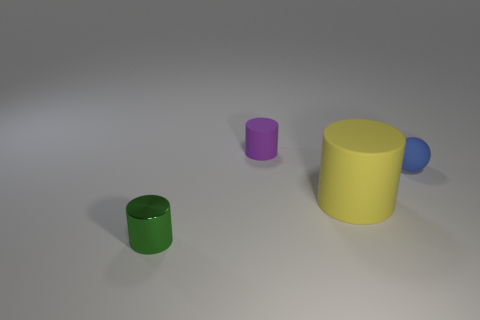How many objects are to the right of the tiny cylinder on the right side of the small cylinder to the left of the purple cylinder?
Provide a short and direct response. 2. Are there fewer large objects that are right of the blue thing than cylinders that are behind the shiny cylinder?
Your answer should be very brief. Yes. What color is the large object that is the same shape as the tiny green thing?
Ensure brevity in your answer.  Yellow. What size is the blue rubber thing?
Make the answer very short. Small. How many yellow matte cylinders have the same size as the blue ball?
Provide a short and direct response. 0. Is the material of the tiny object right of the tiny rubber cylinder the same as the tiny object that is in front of the blue ball?
Provide a succinct answer. No. Is the number of cylinders greater than the number of objects?
Provide a short and direct response. No. Does the purple object have the same material as the green thing?
Offer a very short reply. No. Are there fewer tiny red shiny things than blue rubber balls?
Your answer should be compact. Yes. Is the big matte object the same shape as the purple object?
Provide a succinct answer. Yes. 